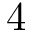Convert formula to latex. <formula><loc_0><loc_0><loc_500><loc_500>4</formula> 